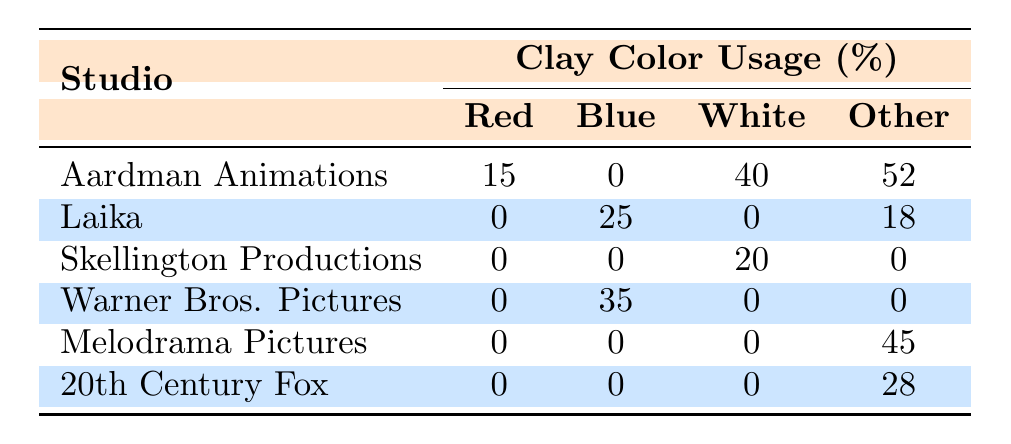What studio used the color blue the most? Looking at the table, Warner Bros. Pictures has the highest usage percentage of blue clay color at 35%.
Answer: Warner Bros. Pictures What is the percentage of red clay used by Aardman Animations? The table shows that Aardman Animations used red clay at a percentage of 15%.
Answer: 15 What is the total percentage of white clay used by Aardman Animations and Skellington Productions combined? Aardman Animations used 40% white clay and Skellington Productions used 20% white clay. Therefore, the combined total percentage is 40% + 20% = 60%.
Answer: 60 Is there any studio that exclusively used white clay? The table indicates that no studio used only white clay because all studios had usage percentages of other colors. Thus, the answer is no.
Answer: No What is the average percentage of green clay across all studios? Only Laika used green clay at a percentage of 18%. Since it's the only data point, the average is 18%.
Answer: 18 